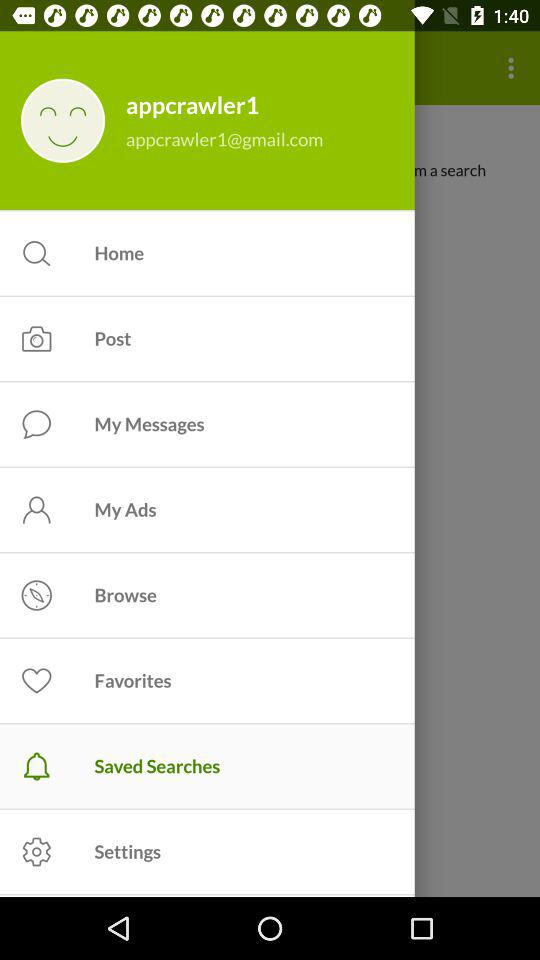What is the email address? The email address is appcrawler1@gmail.com. 